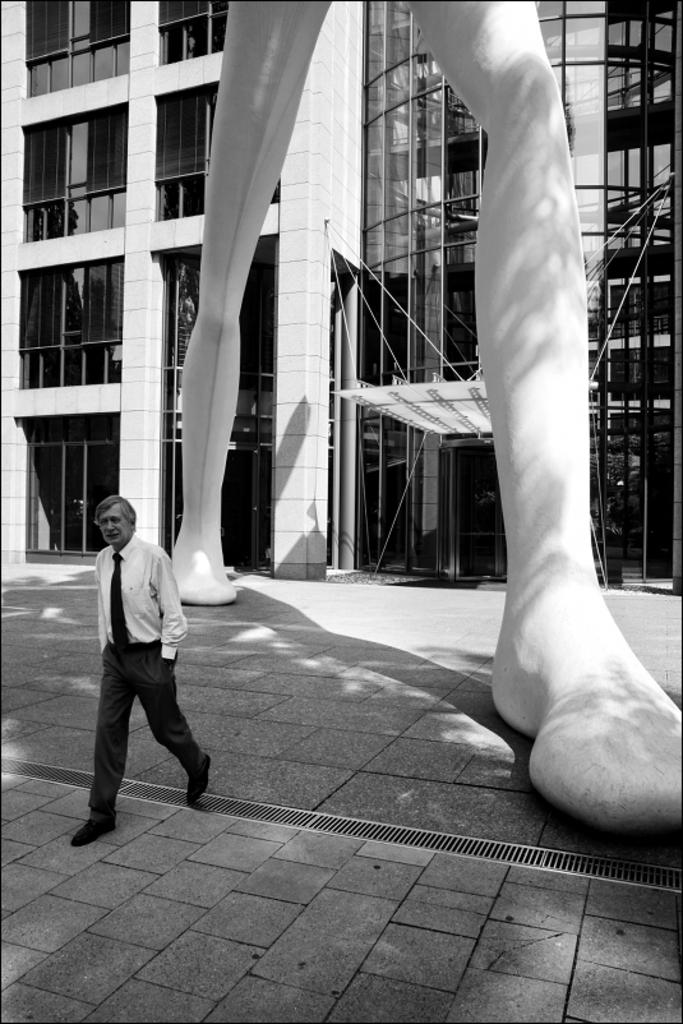What is the main subject of the image? There is a man walking in the center of the image. What can be seen in the background of the image? There is a statue and buildings in the background of the image. What is the color of the statue? The statue is white in color. Is there a volcano visible in the image? No, there is no volcano present in the image. What shape is the statue in the image? The provided facts do not mention the shape of the statue, so we cannot definitively answer this question. 